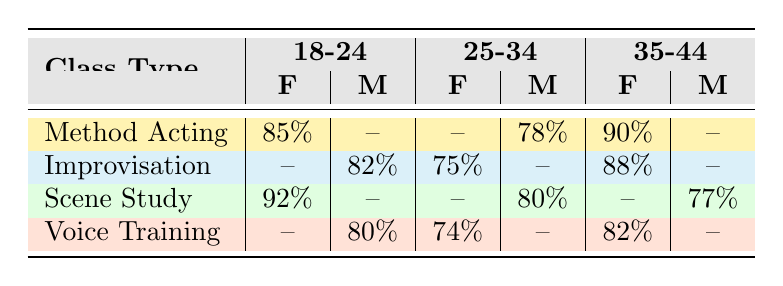What is the attendance rate for Female students in the Method Acting class aged 18-24? The table shows the attendance rate for Female students in the Method Acting class, specifically under the 18-24 age group. Referring to the relevant cell, the attendance rate is 85%.
Answer: 85% What is the attendance rate for Male students in the Scene Study class aged 25-34? Looking at the Scene Study row and filtering for Male students in the 25-34 age group, the attendance rate is shown as 80%.
Answer: 80% Is there any attendance rate for Male students in the Method Acting class? Checking the Method Acting row, there is no attendance rate listed for Male students in any age group. Since it shows "-" for Male in all columns, the answer is no.
Answer: No What is the average attendance rate for Female students across all class types and age groups? First, we identify all rows that pertain to Female students: Method Acting (85%), Method Acting (90%), Improvisation (75%), Improvisation (88%), Scene Study (92%), Voice Training (74%), and Voice Training (82%). The sum is 85 + 90 + 75 + 88 + 92 + 74 + 82 = 506. Since there are 7 entries, the average is 506/7 = 72.29 (rounded).
Answer: 72.29 Which class type has the highest attendance rate for students aged 35-44 and Female? The attendance rates for Female students aged 35-44 across class types are: Method Acting (90%), Improvisation (88%), Scene Study (not applicable), and Voice Training (82%). The highest is 90%, from Method Acting.
Answer: Method Acting What is the total attendance rate for Male students in all classes? Here, we check the attendance rates for Male students: Method Acting (no entry), Improvisation (82%), Scene Study (not applicable), Voice Training (80%). Adding these together gives us 82 + 80 = 162, and since there are 2 entries, the total attendance rate is 162.
Answer: 162 Is the attendance rate for Female students in the Voice Training class aged 25-34 higher than that of Male students in the same class? Looking at the Voice Training row, Female students aged 25-34 have an attendance rate of 74%, while Male students have an attendance rate of 80%. Since 80% is greater than 74%, it is false.
Answer: No Which age group has the lowest attendance rate for Female students in Scene Study? For Female students in Scene Study, we only have the attendance rate for the 18-24 age group (92%) and no entries for the 25-34 and 35-44 age groups. Since there’s only one value, 92% is the lowest compared to non-existent entries.
Answer: 92% 